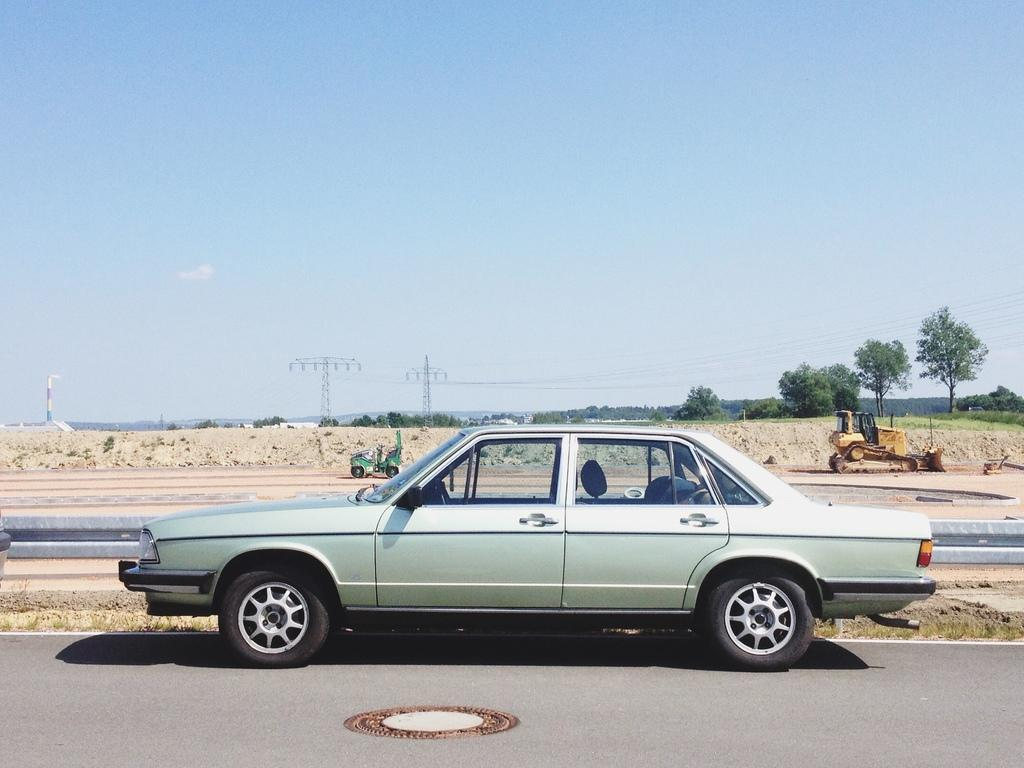What is the main subject of the image? There is a car in the image. Are there any other vehicles in the image? Yes, there are other vehicles on the road in the image. What can be seen in the background of the image? Trees, current poles, and wires are visible in the background. What is the color of the sky in the image? The sky is blue and white in color. Can you tell me how many men are playing with milk in the image? There are no men or milk present in the image. What type of playground equipment can be seen in the image? There is no playground equipment visible in the image. 